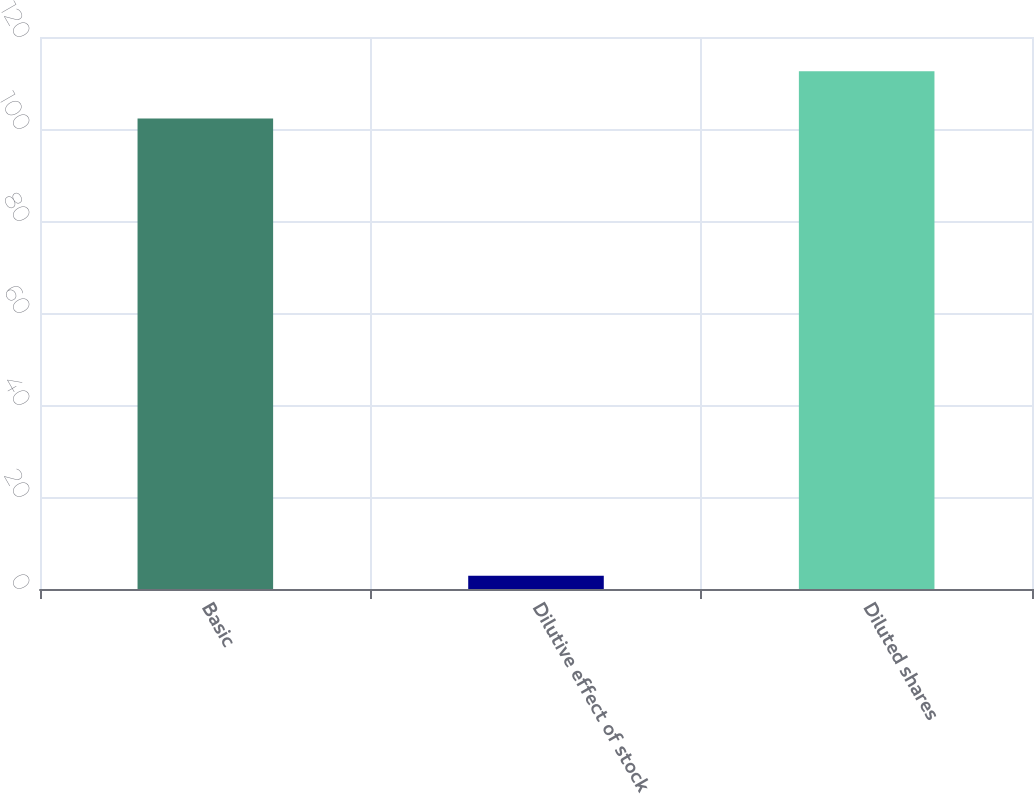<chart> <loc_0><loc_0><loc_500><loc_500><bar_chart><fcel>Basic<fcel>Dilutive effect of stock<fcel>Diluted shares<nl><fcel>102.3<fcel>2.9<fcel>112.53<nl></chart> 